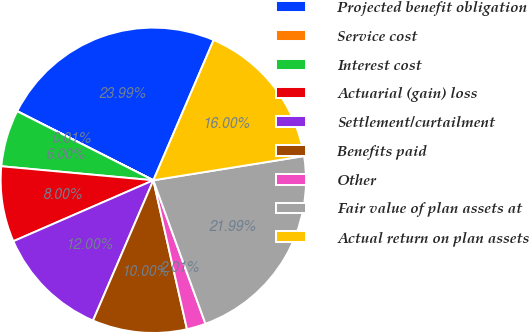Convert chart. <chart><loc_0><loc_0><loc_500><loc_500><pie_chart><fcel>Projected benefit obligation<fcel>Service cost<fcel>Interest cost<fcel>Actuarial (gain) loss<fcel>Settlement/curtailment<fcel>Benefits paid<fcel>Other<fcel>Fair value of plan assets at<fcel>Actual return on plan assets<nl><fcel>23.99%<fcel>0.01%<fcel>6.0%<fcel>8.0%<fcel>12.0%<fcel>10.0%<fcel>2.01%<fcel>21.99%<fcel>16.0%<nl></chart> 